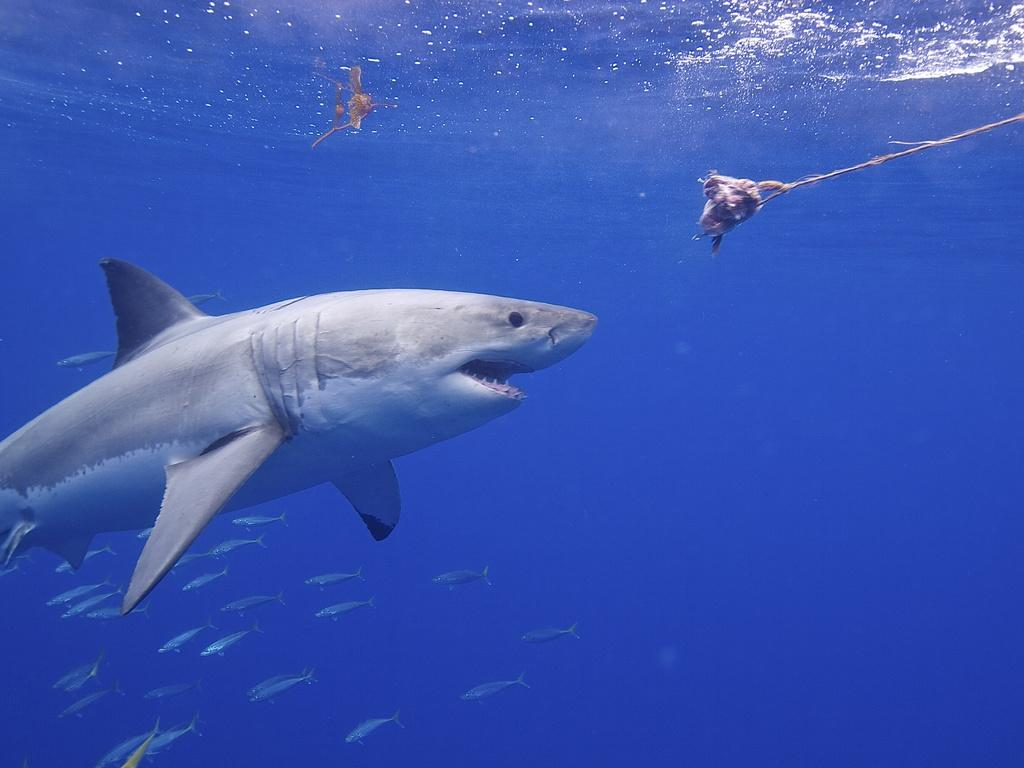What is in the water in the image? There is a shark in the water. What is near the shark? There is a bait in front of the shark. What else can be seen at the bottom of the water? There are small fishes at the bottom of the water. What type of soda is being poured into the water in the image? There is no soda present in the image; it features a shark in the water with bait and small fishes. Can you see a rifle being used to hunt the shark in the image? There is no rifle or hunting activity depicted in the image; it shows a shark with bait and small fishes in the water. 